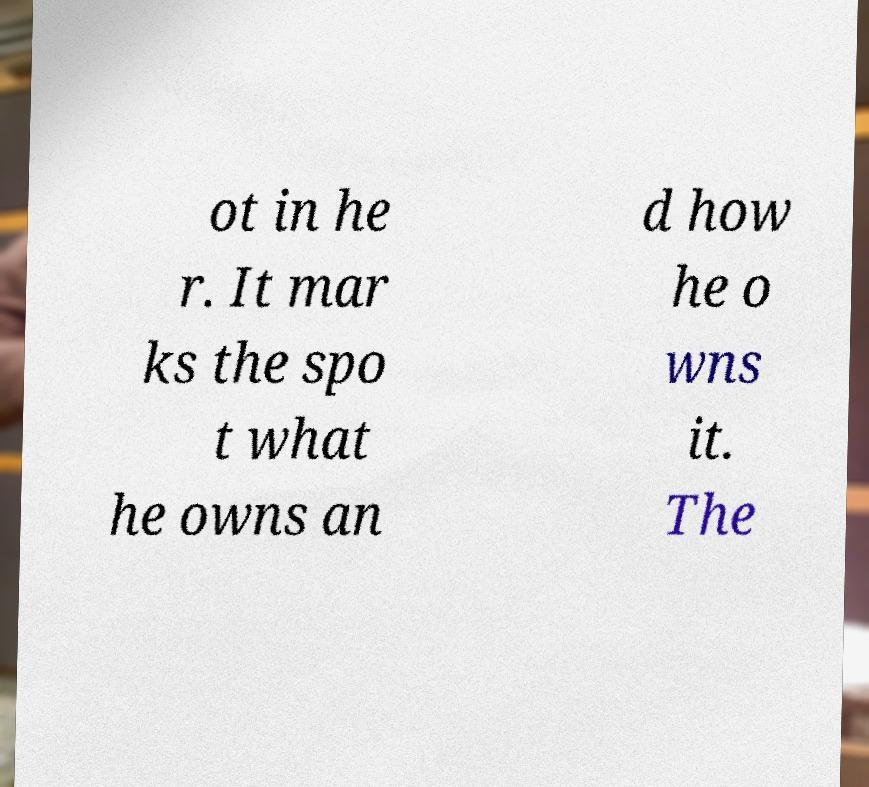Could you extract and type out the text from this image? ot in he r. It mar ks the spo t what he owns an d how he o wns it. The 